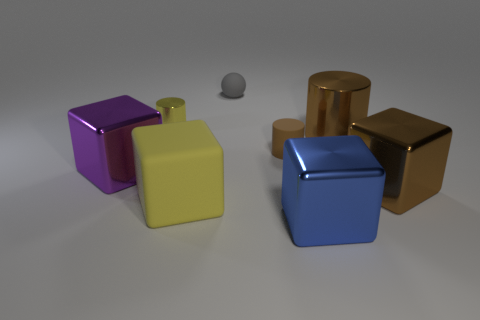Add 2 matte cylinders. How many objects exist? 10 Subtract all balls. How many objects are left? 7 Add 6 small brown matte cylinders. How many small brown matte cylinders are left? 7 Add 4 blocks. How many blocks exist? 8 Subtract 0 blue cylinders. How many objects are left? 8 Subtract all big yellow rubber objects. Subtract all purple cylinders. How many objects are left? 7 